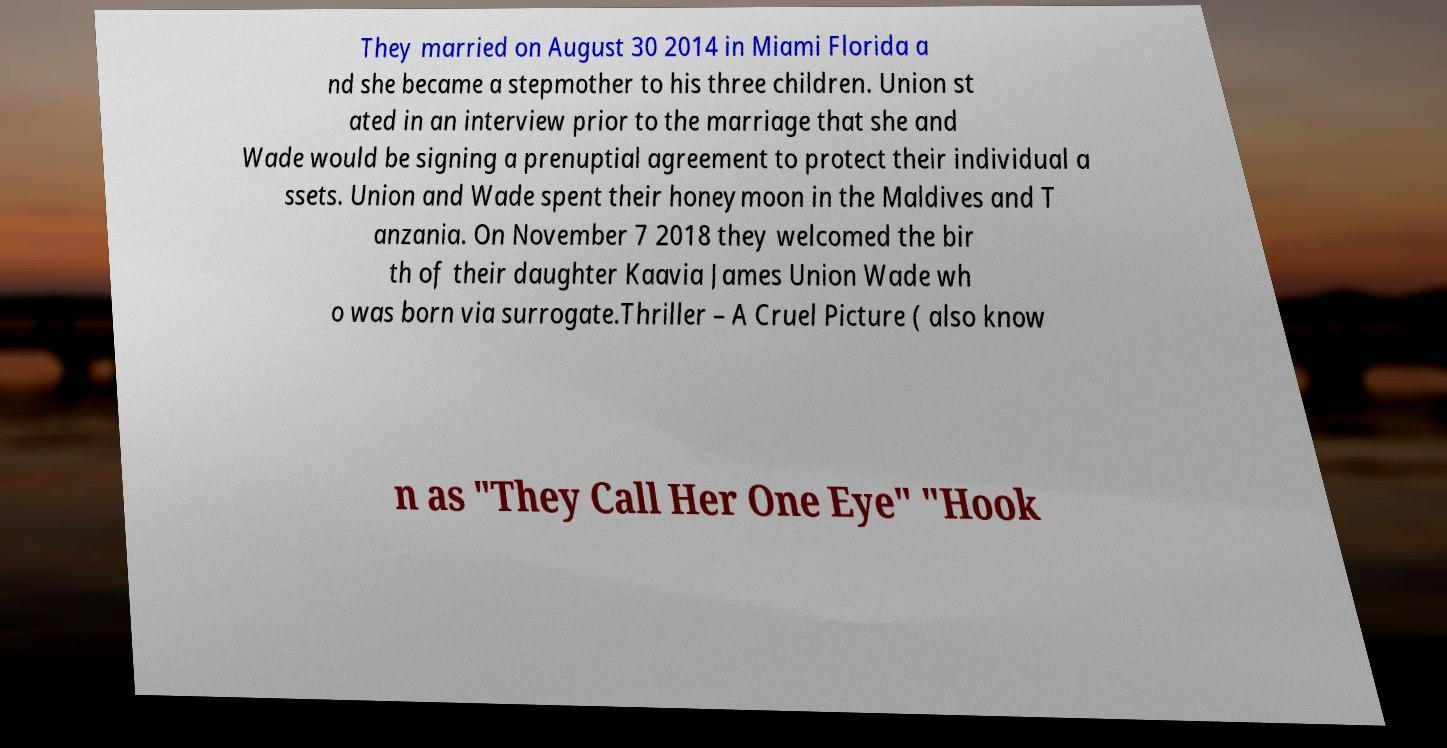What messages or text are displayed in this image? I need them in a readable, typed format. They married on August 30 2014 in Miami Florida a nd she became a stepmother to his three children. Union st ated in an interview prior to the marriage that she and Wade would be signing a prenuptial agreement to protect their individual a ssets. Union and Wade spent their honeymoon in the Maldives and T anzania. On November 7 2018 they welcomed the bir th of their daughter Kaavia James Union Wade wh o was born via surrogate.Thriller – A Cruel Picture ( also know n as "They Call Her One Eye" "Hook 